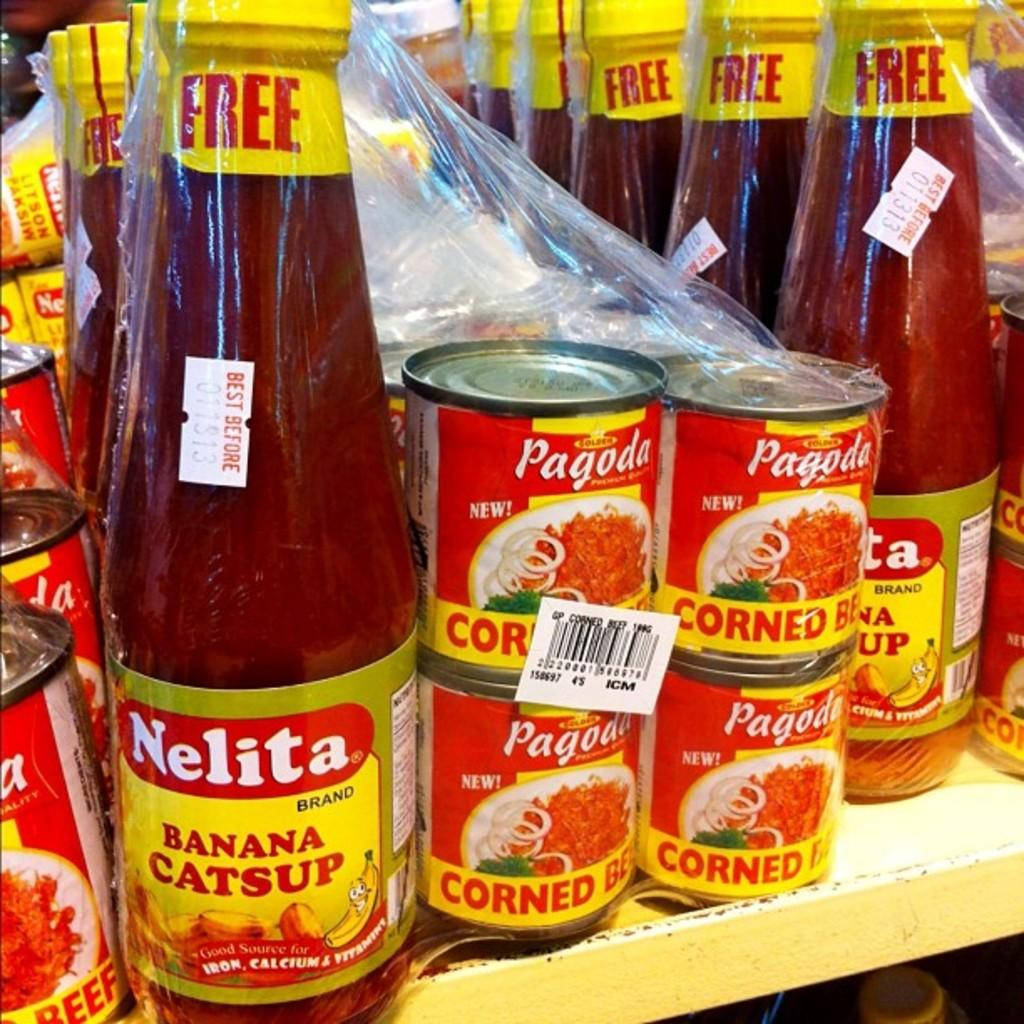<image>
Give a short and clear explanation of the subsequent image. Some Nelita and Pagoda products fill a store shelf. 